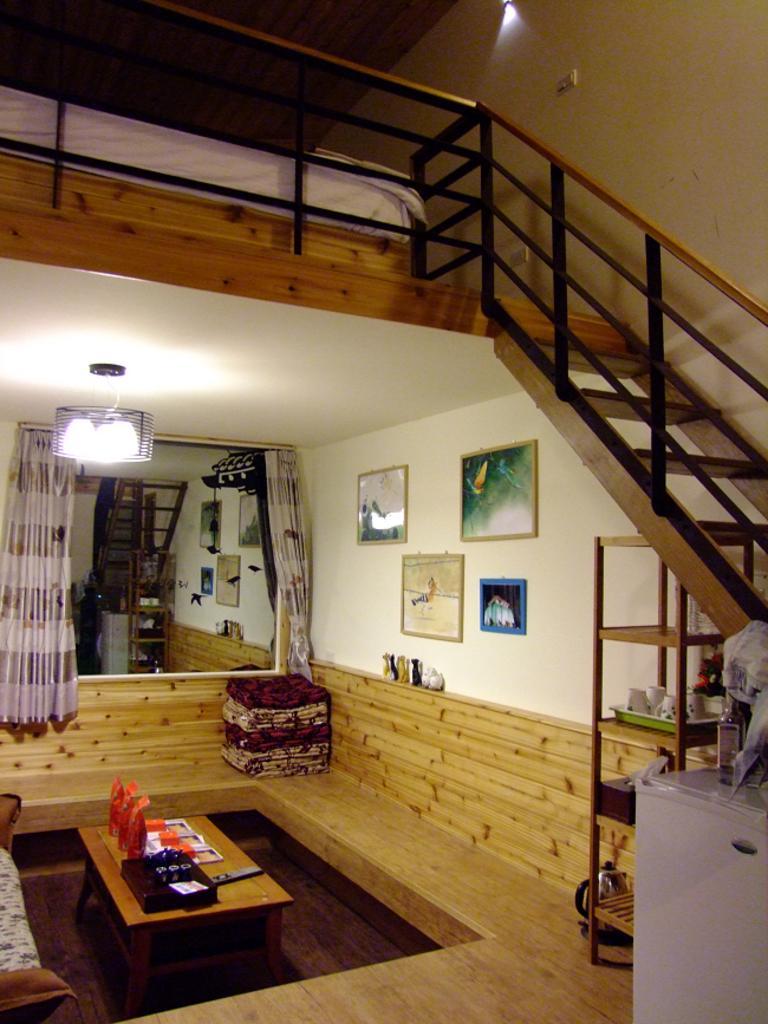Can you describe this image briefly? In this image I can see inside view of room , in the room there is a table, sofa chair , wooden table, on the table there are bed sheets and a rack , in the middle there is a curtain ,wall, photo frames attached to the wall and a light attached to the roof ,there is a stair case visible at the top. 